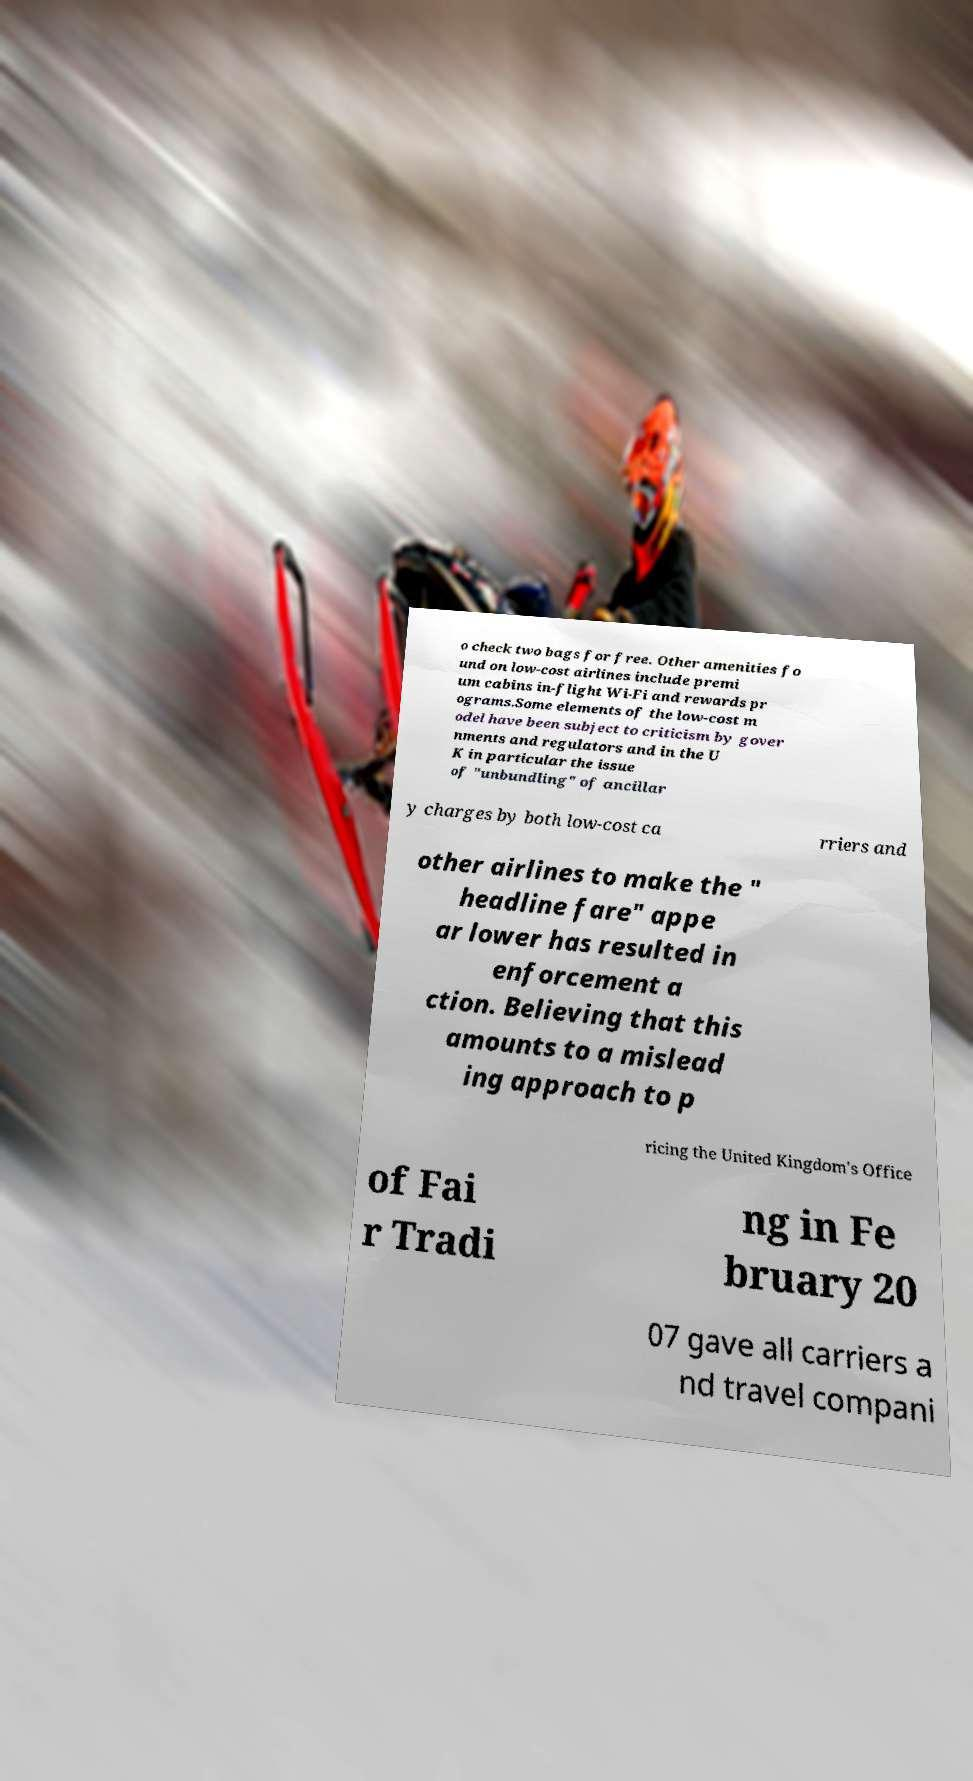There's text embedded in this image that I need extracted. Can you transcribe it verbatim? o check two bags for free. Other amenities fo und on low-cost airlines include premi um cabins in-flight Wi-Fi and rewards pr ograms.Some elements of the low-cost m odel have been subject to criticism by gover nments and regulators and in the U K in particular the issue of "unbundling" of ancillar y charges by both low-cost ca rriers and other airlines to make the " headline fare" appe ar lower has resulted in enforcement a ction. Believing that this amounts to a mislead ing approach to p ricing the United Kingdom's Office of Fai r Tradi ng in Fe bruary 20 07 gave all carriers a nd travel compani 